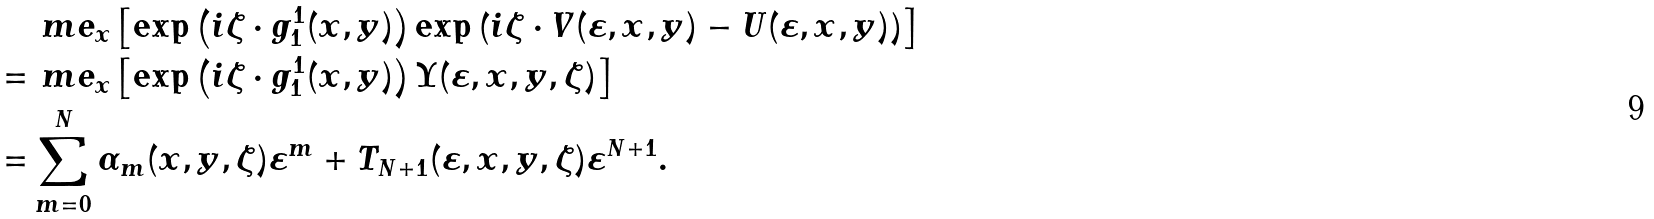<formula> <loc_0><loc_0><loc_500><loc_500>& \ m e _ { x } \left [ \exp \left ( i \zeta \cdot g ^ { 1 } _ { 1 } ( x , y ) \right ) \exp \left ( i \zeta \cdot V ( \varepsilon , x , y ) - U ( \varepsilon , x , y ) \right ) \right ] \\ = & \ m e _ { x } \left [ \exp \left ( i \zeta \cdot g ^ { 1 } _ { 1 } ( x , y ) \right ) \Upsilon ( \varepsilon , x , y , \zeta ) \right ] \\ = & \sum _ { m = 0 } ^ { N } \alpha _ { m } ( x , y , \zeta ) \varepsilon ^ { m } + T _ { N + 1 } ( \varepsilon , x , y , \zeta ) \varepsilon ^ { N + 1 } .</formula> 